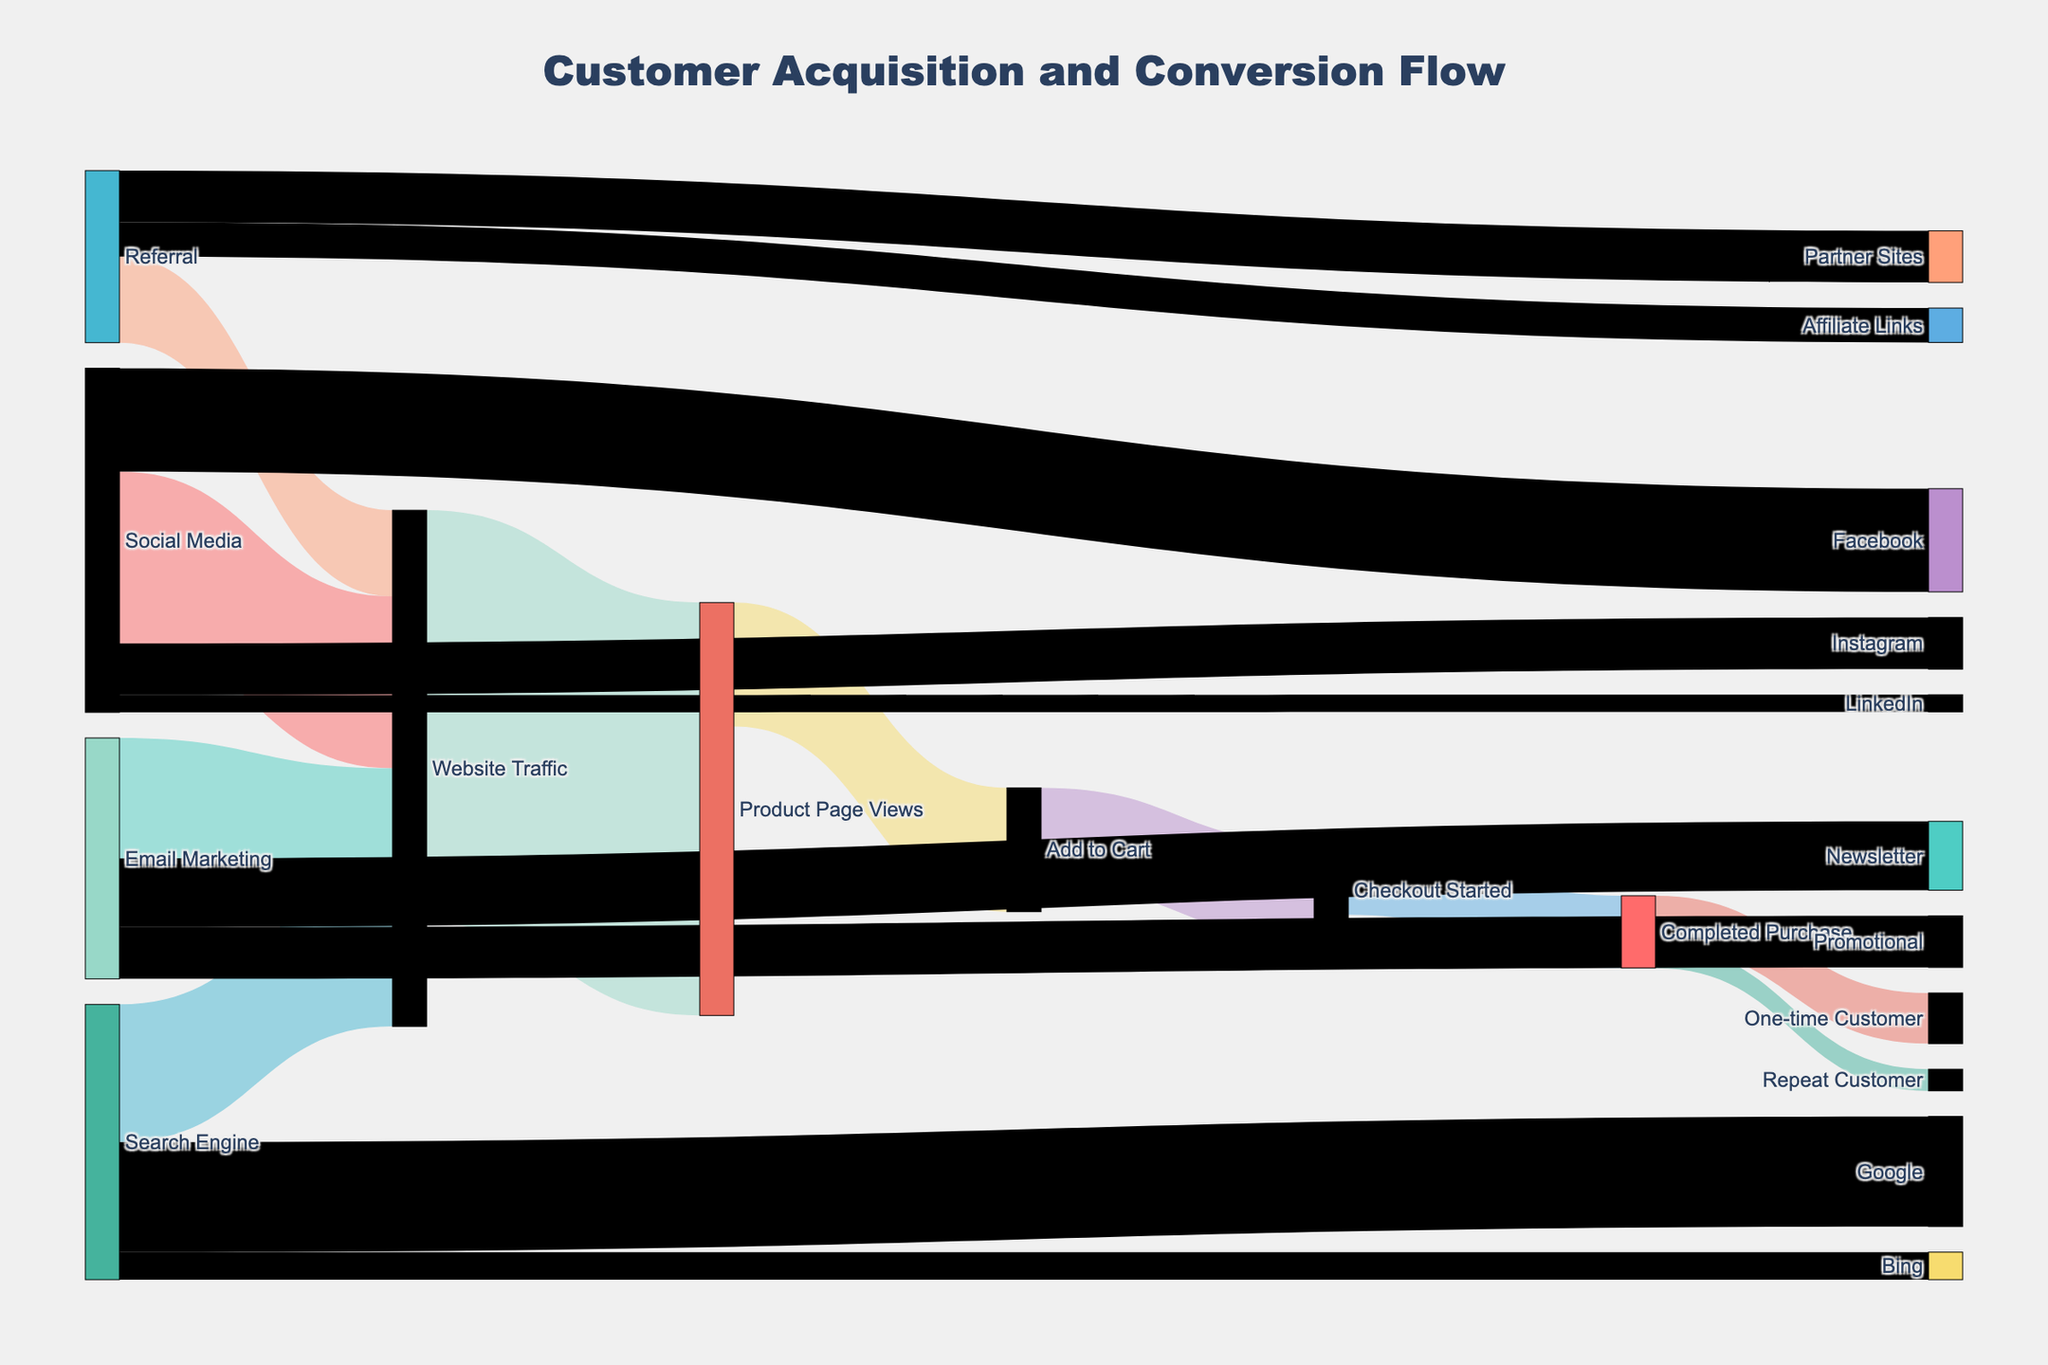How many customers were acquired through Social Media channels? To determine the number of customers acquired through Social Media, sum the values for all subchannels listed under Social Media. The subchannels are Facebook (3000), Instagram (1500), and LinkedIn (500). Adding these values gives: 3000 + 1500 + 500 = 5000.
Answer: 5000 Which customer acquisition channel has the highest contribution to Website Traffic? Look for the source nodes that lead to Website Traffic and compare their values. Social Media contributes 5000, Email Marketing contributes 3500, Search Engine contributes 4000, and Referral contributes 2500. Social Media has the highest contribution with 5000.
Answer: Social Media What is the total number of customers who completed the purchase? The number of customers who completed the purchase equals the value at the 'Completed Purchase' node. The diagram indicates there are 2100 customers at this stage.
Answer: 2100 How many customers who started the checkout process did not complete the purchase? To find the number, subtract the number of 'Completed Purchase' (2100) from 'Checkout Started' (2800). The calculation is 2800 - 2100 = 700.
Answer: 700 Which specific subchannel under the Search Engine source contributes the most? Compare values of subchannels under Search Engine. Google has 3200 and Bing has 800. Google contributes the most with 3200.
Answer: Google What percentage of customers who completed the purchase are repeat customers? To calculate the percentage, divide 'Repeat Customer' (630) by 'Completed Purchase' (2100) and multiply by 100. (630 / 2100) * 100 ≈ 30%.
Answer: 30% What is the conversion rate from Product Page Views to Add to Cart? To find the rate, divide 'Add to Cart' (3600) by 'Product Page Views' (12000) and multiply by 100. (3600 / 12000) * 100 = 30%.
Answer: 30% How does the contribution of Email Marketing to Website Traffic compare to that of Referral? Email Marketing contributes 3500 to Website Traffic, while Referral contributes 2500. Email Marketing contributes more than Referral.
Answer: Email Marketing contributes more Which stage in the purchase funnel has the highest drop-off? Examine the values to identify the greatest decrease between stages. The drop-off between 'Website Traffic' (12000) and 'Product Page Views' (3600) is 8400, which is the highest.
Answer: Between Website Traffic and Product Page Views 